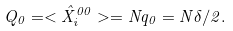Convert formula to latex. <formula><loc_0><loc_0><loc_500><loc_500>Q _ { 0 } = < \hat { X } _ { i } ^ { 0 0 } > = N q _ { 0 } = N \delta / 2 .</formula> 